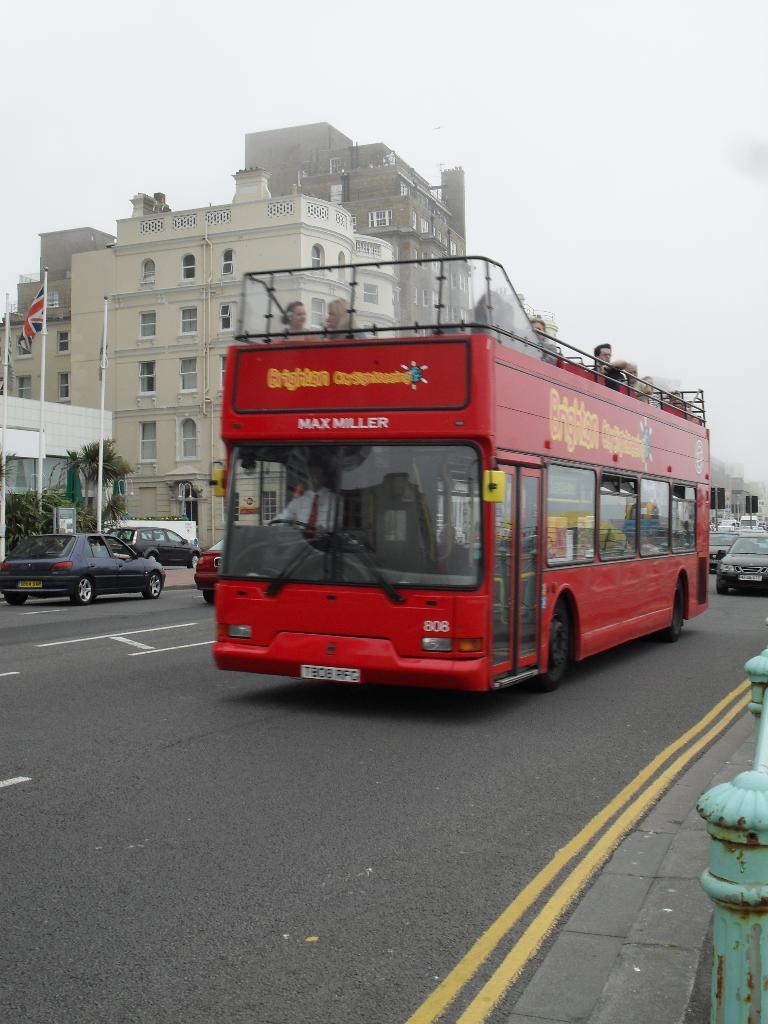In one or two sentences, can you explain what this image depicts? In this image there are vehicle are moving on a road, in the background there are buildings, trees, flagpoles and the sky, on the bottom right there is a railing. 